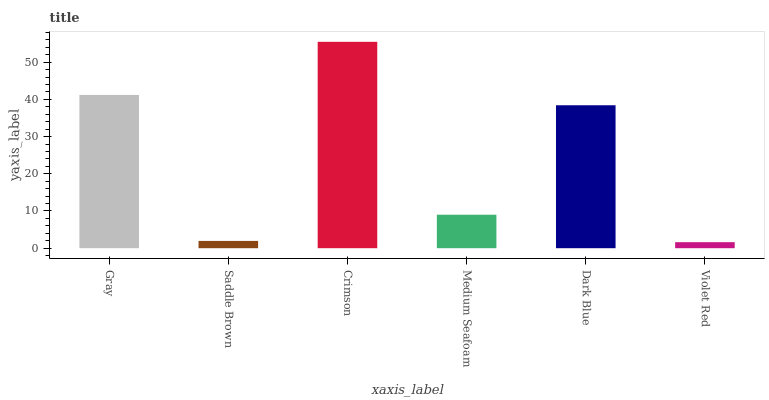Is Violet Red the minimum?
Answer yes or no. Yes. Is Crimson the maximum?
Answer yes or no. Yes. Is Saddle Brown the minimum?
Answer yes or no. No. Is Saddle Brown the maximum?
Answer yes or no. No. Is Gray greater than Saddle Brown?
Answer yes or no. Yes. Is Saddle Brown less than Gray?
Answer yes or no. Yes. Is Saddle Brown greater than Gray?
Answer yes or no. No. Is Gray less than Saddle Brown?
Answer yes or no. No. Is Dark Blue the high median?
Answer yes or no. Yes. Is Medium Seafoam the low median?
Answer yes or no. Yes. Is Medium Seafoam the high median?
Answer yes or no. No. Is Violet Red the low median?
Answer yes or no. No. 